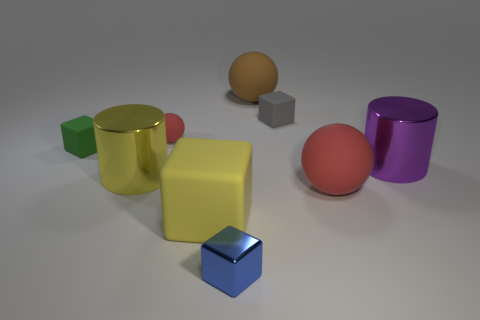Add 1 large purple blocks. How many objects exist? 10 Subtract all cubes. How many objects are left? 5 Subtract all brown things. Subtract all red matte things. How many objects are left? 6 Add 2 red spheres. How many red spheres are left? 4 Add 2 small blue objects. How many small blue objects exist? 3 Subtract 1 yellow cylinders. How many objects are left? 8 